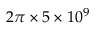Convert formula to latex. <formula><loc_0><loc_0><loc_500><loc_500>2 \pi \times 5 \times 1 0 ^ { 9 }</formula> 